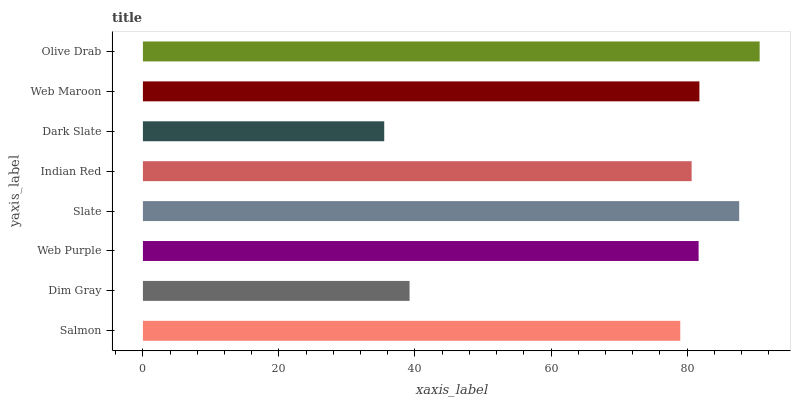Is Dark Slate the minimum?
Answer yes or no. Yes. Is Olive Drab the maximum?
Answer yes or no. Yes. Is Dim Gray the minimum?
Answer yes or no. No. Is Dim Gray the maximum?
Answer yes or no. No. Is Salmon greater than Dim Gray?
Answer yes or no. Yes. Is Dim Gray less than Salmon?
Answer yes or no. Yes. Is Dim Gray greater than Salmon?
Answer yes or no. No. Is Salmon less than Dim Gray?
Answer yes or no. No. Is Web Purple the high median?
Answer yes or no. Yes. Is Indian Red the low median?
Answer yes or no. Yes. Is Dark Slate the high median?
Answer yes or no. No. Is Slate the low median?
Answer yes or no. No. 